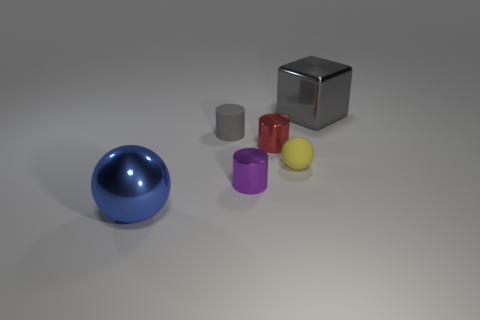What shapes are the objects, and are any two shapes identical? The objects include a sphere, a cube, and three cylinders of different sizes. None of the shapes are exactly identical, but the yellow and silver objects are both cylindrical, though the yellow one is smaller in size. 